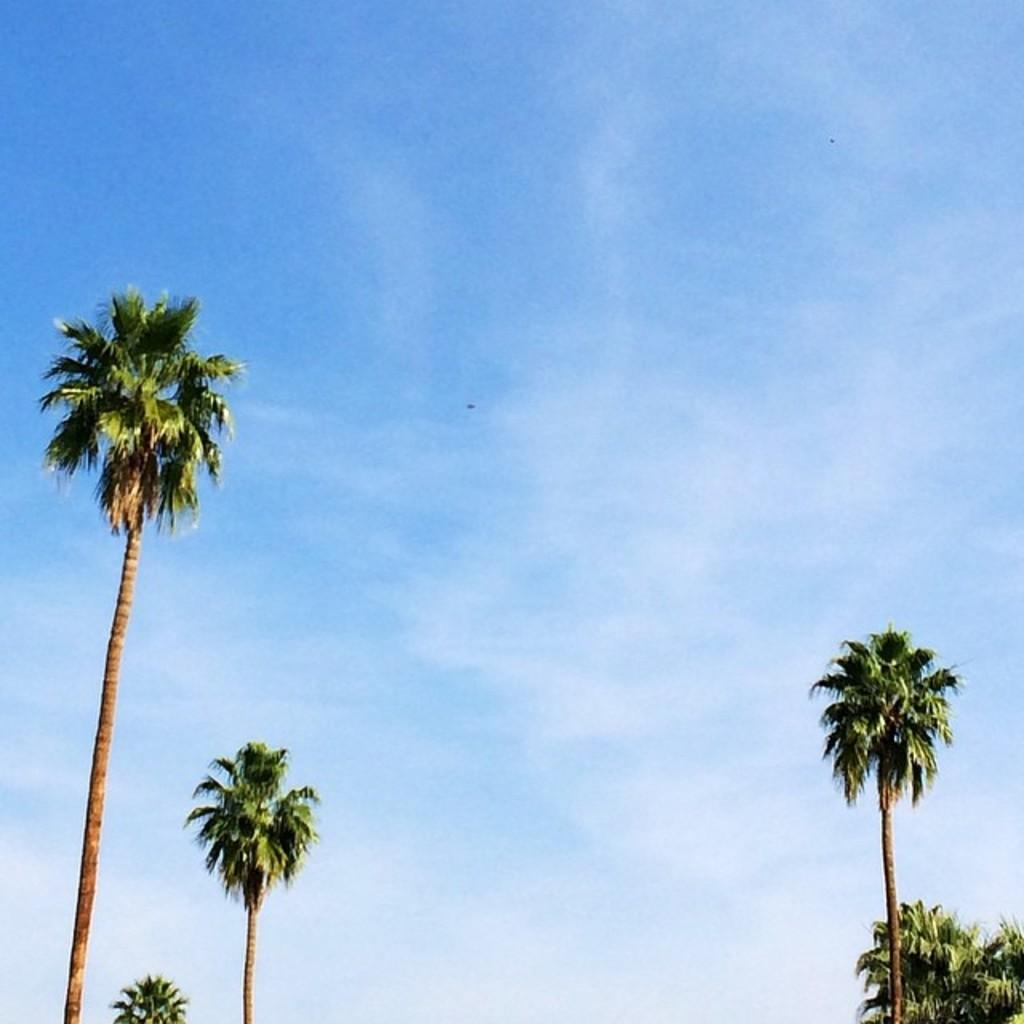What type of vegetation can be seen in the image? There are trees in the image. What is visible at the top of the image? The sky is visible at the top of the image. How many cats can be seen climbing on the roof in the image? There are no cats or roof present in the image; it only features trees and the sky. Is there a cobweb visible in the image? There is no cobweb present in the image. 